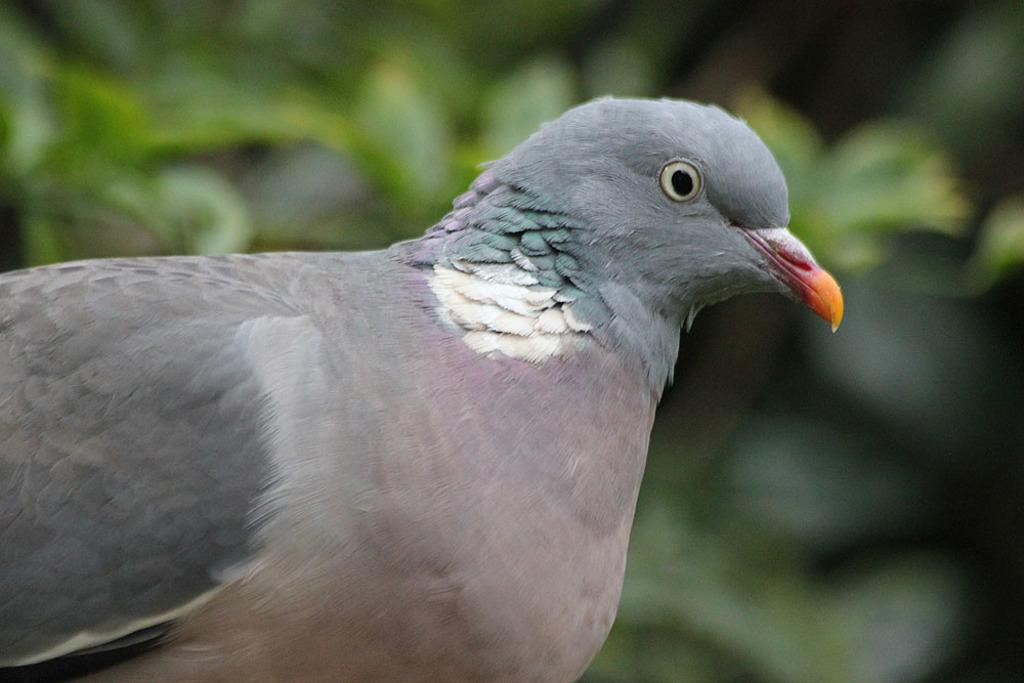What type of bird is in the image? There is a stock dove in the image. What is the stock dove doing in the image? The stock dove is sitting. What can be seen in the background of the image? There are plants in the background of the image. What type of quilt is being used to cover the ducks in the image? There are no ducks or quilts present in the image; it features a stock dove sitting among plants. 